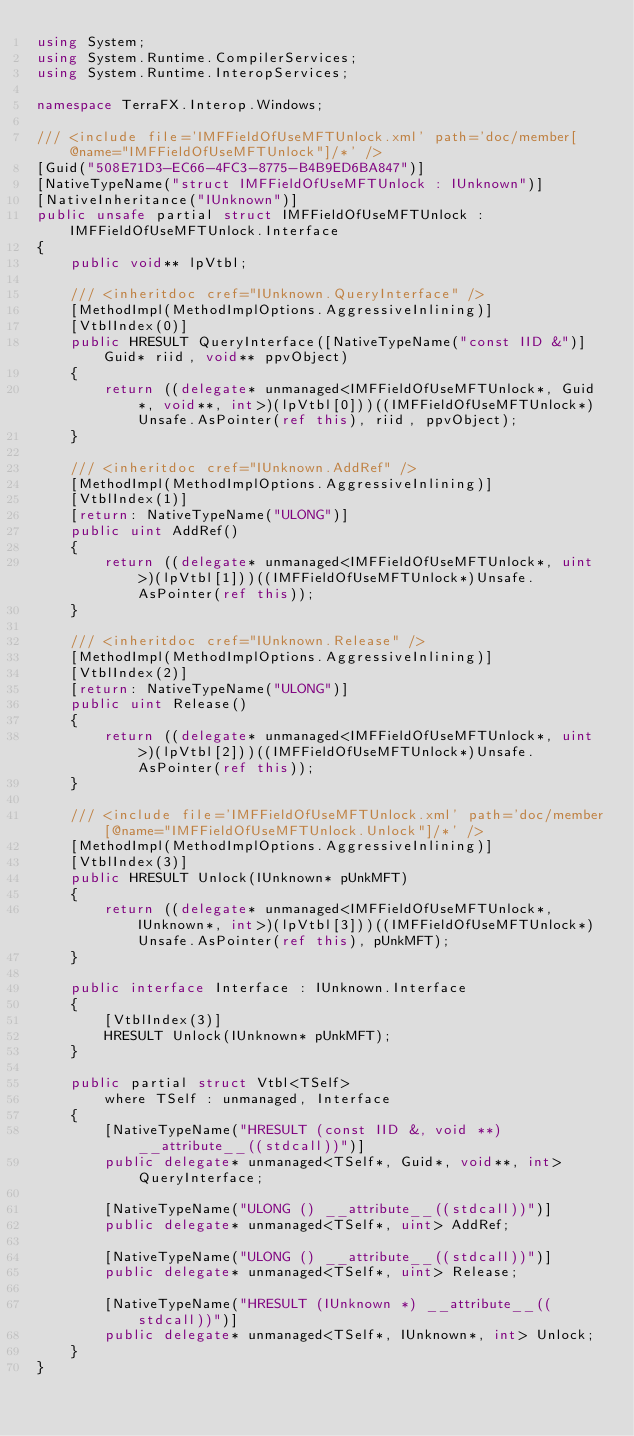<code> <loc_0><loc_0><loc_500><loc_500><_C#_>using System;
using System.Runtime.CompilerServices;
using System.Runtime.InteropServices;

namespace TerraFX.Interop.Windows;

/// <include file='IMFFieldOfUseMFTUnlock.xml' path='doc/member[@name="IMFFieldOfUseMFTUnlock"]/*' />
[Guid("508E71D3-EC66-4FC3-8775-B4B9ED6BA847")]
[NativeTypeName("struct IMFFieldOfUseMFTUnlock : IUnknown")]
[NativeInheritance("IUnknown")]
public unsafe partial struct IMFFieldOfUseMFTUnlock : IMFFieldOfUseMFTUnlock.Interface
{
    public void** lpVtbl;

    /// <inheritdoc cref="IUnknown.QueryInterface" />
    [MethodImpl(MethodImplOptions.AggressiveInlining)]
    [VtblIndex(0)]
    public HRESULT QueryInterface([NativeTypeName("const IID &")] Guid* riid, void** ppvObject)
    {
        return ((delegate* unmanaged<IMFFieldOfUseMFTUnlock*, Guid*, void**, int>)(lpVtbl[0]))((IMFFieldOfUseMFTUnlock*)Unsafe.AsPointer(ref this), riid, ppvObject);
    }

    /// <inheritdoc cref="IUnknown.AddRef" />
    [MethodImpl(MethodImplOptions.AggressiveInlining)]
    [VtblIndex(1)]
    [return: NativeTypeName("ULONG")]
    public uint AddRef()
    {
        return ((delegate* unmanaged<IMFFieldOfUseMFTUnlock*, uint>)(lpVtbl[1]))((IMFFieldOfUseMFTUnlock*)Unsafe.AsPointer(ref this));
    }

    /// <inheritdoc cref="IUnknown.Release" />
    [MethodImpl(MethodImplOptions.AggressiveInlining)]
    [VtblIndex(2)]
    [return: NativeTypeName("ULONG")]
    public uint Release()
    {
        return ((delegate* unmanaged<IMFFieldOfUseMFTUnlock*, uint>)(lpVtbl[2]))((IMFFieldOfUseMFTUnlock*)Unsafe.AsPointer(ref this));
    }

    /// <include file='IMFFieldOfUseMFTUnlock.xml' path='doc/member[@name="IMFFieldOfUseMFTUnlock.Unlock"]/*' />
    [MethodImpl(MethodImplOptions.AggressiveInlining)]
    [VtblIndex(3)]
    public HRESULT Unlock(IUnknown* pUnkMFT)
    {
        return ((delegate* unmanaged<IMFFieldOfUseMFTUnlock*, IUnknown*, int>)(lpVtbl[3]))((IMFFieldOfUseMFTUnlock*)Unsafe.AsPointer(ref this), pUnkMFT);
    }

    public interface Interface : IUnknown.Interface
    {
        [VtblIndex(3)]
        HRESULT Unlock(IUnknown* pUnkMFT);
    }

    public partial struct Vtbl<TSelf>
        where TSelf : unmanaged, Interface
    {
        [NativeTypeName("HRESULT (const IID &, void **) __attribute__((stdcall))")]
        public delegate* unmanaged<TSelf*, Guid*, void**, int> QueryInterface;

        [NativeTypeName("ULONG () __attribute__((stdcall))")]
        public delegate* unmanaged<TSelf*, uint> AddRef;

        [NativeTypeName("ULONG () __attribute__((stdcall))")]
        public delegate* unmanaged<TSelf*, uint> Release;

        [NativeTypeName("HRESULT (IUnknown *) __attribute__((stdcall))")]
        public delegate* unmanaged<TSelf*, IUnknown*, int> Unlock;
    }
}
</code> 